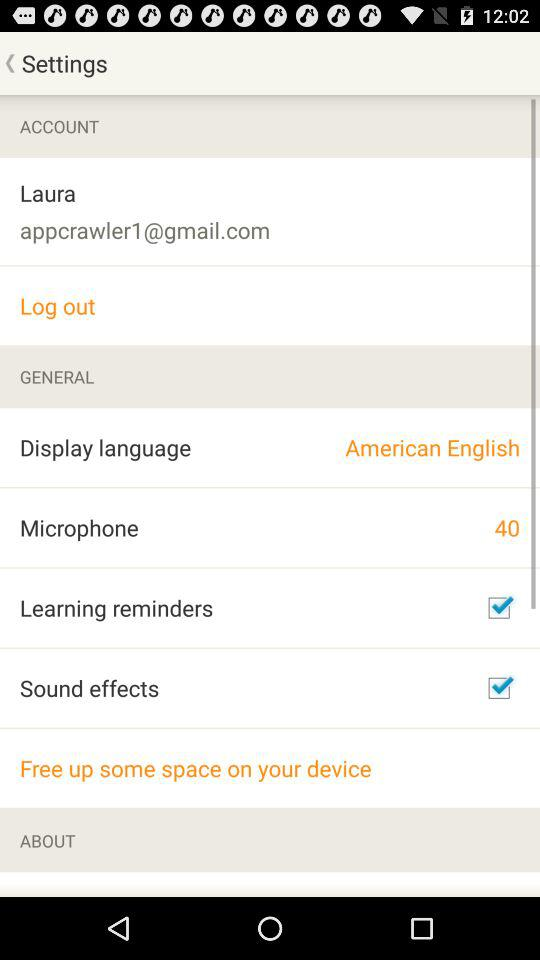What is the status of "Learning reminders"? The status of "Learning reminders" is "on". 